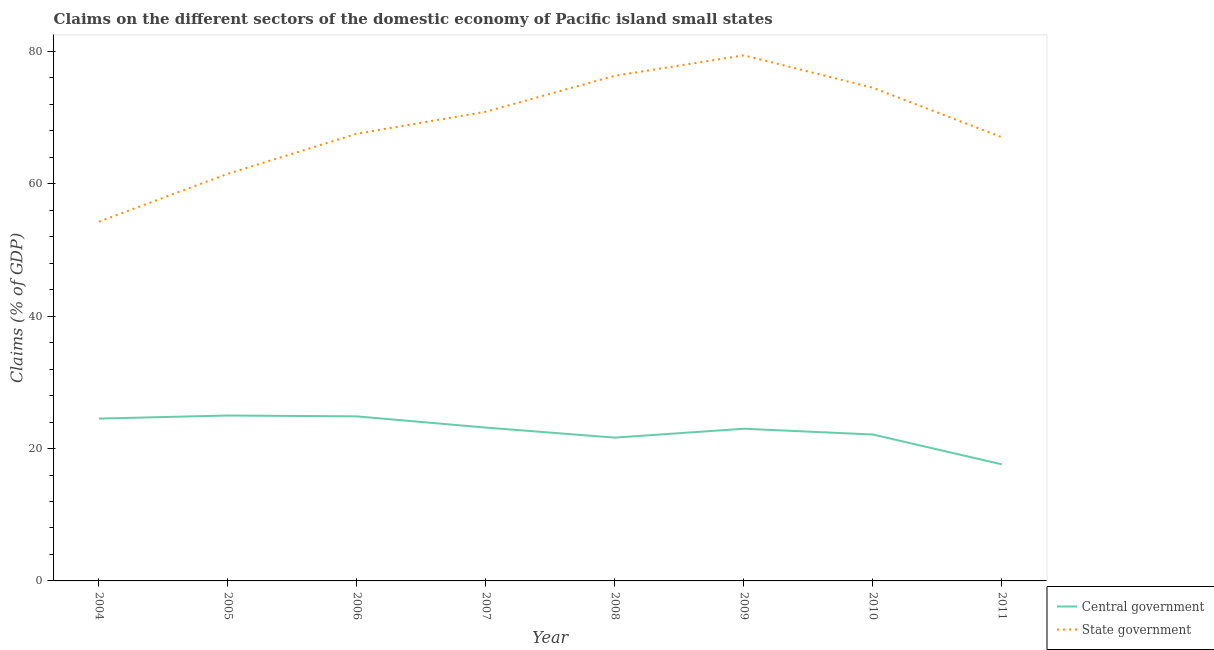What is the claims on state government in 2008?
Give a very brief answer. 76.31. Across all years, what is the maximum claims on state government?
Provide a succinct answer. 79.4. Across all years, what is the minimum claims on state government?
Provide a succinct answer. 54.27. In which year was the claims on central government maximum?
Offer a terse response. 2005. What is the total claims on state government in the graph?
Your response must be concise. 551.47. What is the difference between the claims on state government in 2007 and that in 2010?
Give a very brief answer. -3.62. What is the difference between the claims on central government in 2009 and the claims on state government in 2004?
Keep it short and to the point. -31.28. What is the average claims on central government per year?
Your response must be concise. 22.74. In the year 2011, what is the difference between the claims on central government and claims on state government?
Give a very brief answer. -49.42. In how many years, is the claims on central government greater than 40 %?
Your answer should be compact. 0. What is the ratio of the claims on central government in 2004 to that in 2009?
Keep it short and to the point. 1.07. Is the claims on state government in 2006 less than that in 2009?
Offer a terse response. Yes. Is the difference between the claims on state government in 2007 and 2009 greater than the difference between the claims on central government in 2007 and 2009?
Provide a succinct answer. No. What is the difference between the highest and the second highest claims on state government?
Provide a short and direct response. 3.09. What is the difference between the highest and the lowest claims on central government?
Ensure brevity in your answer.  7.38. In how many years, is the claims on central government greater than the average claims on central government taken over all years?
Give a very brief answer. 5. Does the claims on state government monotonically increase over the years?
Provide a short and direct response. No. Is the claims on state government strictly greater than the claims on central government over the years?
Offer a terse response. Yes. Is the claims on central government strictly less than the claims on state government over the years?
Ensure brevity in your answer.  Yes. How many lines are there?
Offer a terse response. 2. What is the difference between two consecutive major ticks on the Y-axis?
Keep it short and to the point. 20. Are the values on the major ticks of Y-axis written in scientific E-notation?
Your answer should be compact. No. Does the graph contain grids?
Offer a terse response. No. Where does the legend appear in the graph?
Provide a succinct answer. Bottom right. How are the legend labels stacked?
Offer a very short reply. Vertical. What is the title of the graph?
Offer a very short reply. Claims on the different sectors of the domestic economy of Pacific island small states. What is the label or title of the X-axis?
Your answer should be compact. Year. What is the label or title of the Y-axis?
Provide a succinct answer. Claims (% of GDP). What is the Claims (% of GDP) in Central government in 2004?
Offer a terse response. 24.52. What is the Claims (% of GDP) of State government in 2004?
Make the answer very short. 54.27. What is the Claims (% of GDP) in Central government in 2005?
Provide a succinct answer. 24.99. What is the Claims (% of GDP) of State government in 2005?
Give a very brief answer. 61.51. What is the Claims (% of GDP) of Central government in 2006?
Your response must be concise. 24.86. What is the Claims (% of GDP) in State government in 2006?
Your response must be concise. 67.56. What is the Claims (% of GDP) in Central government in 2007?
Provide a short and direct response. 23.16. What is the Claims (% of GDP) in State government in 2007?
Give a very brief answer. 70.88. What is the Claims (% of GDP) of Central government in 2008?
Your answer should be very brief. 21.65. What is the Claims (% of GDP) in State government in 2008?
Give a very brief answer. 76.31. What is the Claims (% of GDP) of Central government in 2009?
Offer a very short reply. 22.99. What is the Claims (% of GDP) in State government in 2009?
Provide a short and direct response. 79.4. What is the Claims (% of GDP) of Central government in 2010?
Provide a succinct answer. 22.12. What is the Claims (% of GDP) in State government in 2010?
Offer a terse response. 74.5. What is the Claims (% of GDP) of Central government in 2011?
Offer a very short reply. 17.61. What is the Claims (% of GDP) of State government in 2011?
Your answer should be compact. 67.03. Across all years, what is the maximum Claims (% of GDP) in Central government?
Your response must be concise. 24.99. Across all years, what is the maximum Claims (% of GDP) of State government?
Offer a very short reply. 79.4. Across all years, what is the minimum Claims (% of GDP) of Central government?
Keep it short and to the point. 17.61. Across all years, what is the minimum Claims (% of GDP) in State government?
Give a very brief answer. 54.27. What is the total Claims (% of GDP) of Central government in the graph?
Ensure brevity in your answer.  181.9. What is the total Claims (% of GDP) of State government in the graph?
Your response must be concise. 551.47. What is the difference between the Claims (% of GDP) in Central government in 2004 and that in 2005?
Offer a terse response. -0.47. What is the difference between the Claims (% of GDP) of State government in 2004 and that in 2005?
Provide a succinct answer. -7.24. What is the difference between the Claims (% of GDP) of Central government in 2004 and that in 2006?
Keep it short and to the point. -0.34. What is the difference between the Claims (% of GDP) in State government in 2004 and that in 2006?
Offer a terse response. -13.29. What is the difference between the Claims (% of GDP) of Central government in 2004 and that in 2007?
Offer a terse response. 1.36. What is the difference between the Claims (% of GDP) in State government in 2004 and that in 2007?
Provide a succinct answer. -16.61. What is the difference between the Claims (% of GDP) in Central government in 2004 and that in 2008?
Give a very brief answer. 2.87. What is the difference between the Claims (% of GDP) of State government in 2004 and that in 2008?
Your answer should be compact. -22.04. What is the difference between the Claims (% of GDP) of Central government in 2004 and that in 2009?
Offer a terse response. 1.53. What is the difference between the Claims (% of GDP) in State government in 2004 and that in 2009?
Give a very brief answer. -25.13. What is the difference between the Claims (% of GDP) of Central government in 2004 and that in 2010?
Keep it short and to the point. 2.4. What is the difference between the Claims (% of GDP) of State government in 2004 and that in 2010?
Make the answer very short. -20.23. What is the difference between the Claims (% of GDP) of Central government in 2004 and that in 2011?
Ensure brevity in your answer.  6.91. What is the difference between the Claims (% of GDP) of State government in 2004 and that in 2011?
Offer a terse response. -12.76. What is the difference between the Claims (% of GDP) in Central government in 2005 and that in 2006?
Offer a terse response. 0.13. What is the difference between the Claims (% of GDP) in State government in 2005 and that in 2006?
Provide a short and direct response. -6.05. What is the difference between the Claims (% of GDP) of Central government in 2005 and that in 2007?
Give a very brief answer. 1.83. What is the difference between the Claims (% of GDP) of State government in 2005 and that in 2007?
Your response must be concise. -9.37. What is the difference between the Claims (% of GDP) of Central government in 2005 and that in 2008?
Ensure brevity in your answer.  3.34. What is the difference between the Claims (% of GDP) of State government in 2005 and that in 2008?
Keep it short and to the point. -14.8. What is the difference between the Claims (% of GDP) of Central government in 2005 and that in 2009?
Your answer should be compact. 2. What is the difference between the Claims (% of GDP) of State government in 2005 and that in 2009?
Your response must be concise. -17.89. What is the difference between the Claims (% of GDP) in Central government in 2005 and that in 2010?
Make the answer very short. 2.87. What is the difference between the Claims (% of GDP) in State government in 2005 and that in 2010?
Keep it short and to the point. -12.99. What is the difference between the Claims (% of GDP) of Central government in 2005 and that in 2011?
Offer a very short reply. 7.38. What is the difference between the Claims (% of GDP) in State government in 2005 and that in 2011?
Keep it short and to the point. -5.52. What is the difference between the Claims (% of GDP) in Central government in 2006 and that in 2007?
Ensure brevity in your answer.  1.69. What is the difference between the Claims (% of GDP) of State government in 2006 and that in 2007?
Provide a succinct answer. -3.32. What is the difference between the Claims (% of GDP) in Central government in 2006 and that in 2008?
Offer a terse response. 3.21. What is the difference between the Claims (% of GDP) of State government in 2006 and that in 2008?
Make the answer very short. -8.75. What is the difference between the Claims (% of GDP) of Central government in 2006 and that in 2009?
Give a very brief answer. 1.87. What is the difference between the Claims (% of GDP) in State government in 2006 and that in 2009?
Provide a succinct answer. -11.84. What is the difference between the Claims (% of GDP) of Central government in 2006 and that in 2010?
Offer a very short reply. 2.74. What is the difference between the Claims (% of GDP) of State government in 2006 and that in 2010?
Provide a short and direct response. -6.94. What is the difference between the Claims (% of GDP) of Central government in 2006 and that in 2011?
Your response must be concise. 7.25. What is the difference between the Claims (% of GDP) of State government in 2006 and that in 2011?
Your answer should be compact. 0.53. What is the difference between the Claims (% of GDP) in Central government in 2007 and that in 2008?
Your answer should be compact. 1.52. What is the difference between the Claims (% of GDP) in State government in 2007 and that in 2008?
Your answer should be very brief. -5.43. What is the difference between the Claims (% of GDP) of Central government in 2007 and that in 2009?
Provide a short and direct response. 0.17. What is the difference between the Claims (% of GDP) in State government in 2007 and that in 2009?
Offer a terse response. -8.52. What is the difference between the Claims (% of GDP) in Central government in 2007 and that in 2010?
Provide a short and direct response. 1.05. What is the difference between the Claims (% of GDP) of State government in 2007 and that in 2010?
Your answer should be compact. -3.62. What is the difference between the Claims (% of GDP) in Central government in 2007 and that in 2011?
Your answer should be compact. 5.55. What is the difference between the Claims (% of GDP) of State government in 2007 and that in 2011?
Offer a terse response. 3.85. What is the difference between the Claims (% of GDP) of Central government in 2008 and that in 2009?
Your answer should be compact. -1.34. What is the difference between the Claims (% of GDP) of State government in 2008 and that in 2009?
Give a very brief answer. -3.09. What is the difference between the Claims (% of GDP) of Central government in 2008 and that in 2010?
Give a very brief answer. -0.47. What is the difference between the Claims (% of GDP) of State government in 2008 and that in 2010?
Your answer should be very brief. 1.81. What is the difference between the Claims (% of GDP) in Central government in 2008 and that in 2011?
Provide a short and direct response. 4.04. What is the difference between the Claims (% of GDP) of State government in 2008 and that in 2011?
Your answer should be very brief. 9.28. What is the difference between the Claims (% of GDP) of Central government in 2009 and that in 2010?
Ensure brevity in your answer.  0.87. What is the difference between the Claims (% of GDP) of State government in 2009 and that in 2010?
Provide a short and direct response. 4.9. What is the difference between the Claims (% of GDP) of Central government in 2009 and that in 2011?
Your answer should be very brief. 5.38. What is the difference between the Claims (% of GDP) of State government in 2009 and that in 2011?
Make the answer very short. 12.37. What is the difference between the Claims (% of GDP) of Central government in 2010 and that in 2011?
Make the answer very short. 4.5. What is the difference between the Claims (% of GDP) of State government in 2010 and that in 2011?
Your answer should be compact. 7.47. What is the difference between the Claims (% of GDP) of Central government in 2004 and the Claims (% of GDP) of State government in 2005?
Your response must be concise. -36.99. What is the difference between the Claims (% of GDP) in Central government in 2004 and the Claims (% of GDP) in State government in 2006?
Keep it short and to the point. -43.04. What is the difference between the Claims (% of GDP) of Central government in 2004 and the Claims (% of GDP) of State government in 2007?
Offer a very short reply. -46.36. What is the difference between the Claims (% of GDP) of Central government in 2004 and the Claims (% of GDP) of State government in 2008?
Offer a very short reply. -51.79. What is the difference between the Claims (% of GDP) of Central government in 2004 and the Claims (% of GDP) of State government in 2009?
Your answer should be very brief. -54.88. What is the difference between the Claims (% of GDP) in Central government in 2004 and the Claims (% of GDP) in State government in 2010?
Your answer should be compact. -49.98. What is the difference between the Claims (% of GDP) of Central government in 2004 and the Claims (% of GDP) of State government in 2011?
Your answer should be very brief. -42.51. What is the difference between the Claims (% of GDP) in Central government in 2005 and the Claims (% of GDP) in State government in 2006?
Give a very brief answer. -42.57. What is the difference between the Claims (% of GDP) in Central government in 2005 and the Claims (% of GDP) in State government in 2007?
Keep it short and to the point. -45.89. What is the difference between the Claims (% of GDP) in Central government in 2005 and the Claims (% of GDP) in State government in 2008?
Give a very brief answer. -51.32. What is the difference between the Claims (% of GDP) of Central government in 2005 and the Claims (% of GDP) of State government in 2009?
Your answer should be very brief. -54.41. What is the difference between the Claims (% of GDP) in Central government in 2005 and the Claims (% of GDP) in State government in 2010?
Make the answer very short. -49.51. What is the difference between the Claims (% of GDP) in Central government in 2005 and the Claims (% of GDP) in State government in 2011?
Provide a short and direct response. -42.04. What is the difference between the Claims (% of GDP) in Central government in 2006 and the Claims (% of GDP) in State government in 2007?
Your answer should be very brief. -46.02. What is the difference between the Claims (% of GDP) in Central government in 2006 and the Claims (% of GDP) in State government in 2008?
Make the answer very short. -51.46. What is the difference between the Claims (% of GDP) in Central government in 2006 and the Claims (% of GDP) in State government in 2009?
Make the answer very short. -54.54. What is the difference between the Claims (% of GDP) of Central government in 2006 and the Claims (% of GDP) of State government in 2010?
Offer a very short reply. -49.64. What is the difference between the Claims (% of GDP) in Central government in 2006 and the Claims (% of GDP) in State government in 2011?
Give a very brief answer. -42.17. What is the difference between the Claims (% of GDP) of Central government in 2007 and the Claims (% of GDP) of State government in 2008?
Ensure brevity in your answer.  -53.15. What is the difference between the Claims (% of GDP) of Central government in 2007 and the Claims (% of GDP) of State government in 2009?
Provide a short and direct response. -56.24. What is the difference between the Claims (% of GDP) of Central government in 2007 and the Claims (% of GDP) of State government in 2010?
Provide a short and direct response. -51.34. What is the difference between the Claims (% of GDP) of Central government in 2007 and the Claims (% of GDP) of State government in 2011?
Make the answer very short. -43.87. What is the difference between the Claims (% of GDP) of Central government in 2008 and the Claims (% of GDP) of State government in 2009?
Give a very brief answer. -57.75. What is the difference between the Claims (% of GDP) of Central government in 2008 and the Claims (% of GDP) of State government in 2010?
Offer a terse response. -52.85. What is the difference between the Claims (% of GDP) of Central government in 2008 and the Claims (% of GDP) of State government in 2011?
Make the answer very short. -45.38. What is the difference between the Claims (% of GDP) in Central government in 2009 and the Claims (% of GDP) in State government in 2010?
Your answer should be compact. -51.51. What is the difference between the Claims (% of GDP) in Central government in 2009 and the Claims (% of GDP) in State government in 2011?
Your response must be concise. -44.04. What is the difference between the Claims (% of GDP) of Central government in 2010 and the Claims (% of GDP) of State government in 2011?
Keep it short and to the point. -44.91. What is the average Claims (% of GDP) in Central government per year?
Make the answer very short. 22.74. What is the average Claims (% of GDP) of State government per year?
Offer a terse response. 68.93. In the year 2004, what is the difference between the Claims (% of GDP) in Central government and Claims (% of GDP) in State government?
Keep it short and to the point. -29.75. In the year 2005, what is the difference between the Claims (% of GDP) in Central government and Claims (% of GDP) in State government?
Make the answer very short. -36.52. In the year 2006, what is the difference between the Claims (% of GDP) of Central government and Claims (% of GDP) of State government?
Make the answer very short. -42.7. In the year 2007, what is the difference between the Claims (% of GDP) of Central government and Claims (% of GDP) of State government?
Your answer should be very brief. -47.71. In the year 2008, what is the difference between the Claims (% of GDP) in Central government and Claims (% of GDP) in State government?
Keep it short and to the point. -54.66. In the year 2009, what is the difference between the Claims (% of GDP) in Central government and Claims (% of GDP) in State government?
Offer a very short reply. -56.41. In the year 2010, what is the difference between the Claims (% of GDP) of Central government and Claims (% of GDP) of State government?
Provide a short and direct response. -52.38. In the year 2011, what is the difference between the Claims (% of GDP) in Central government and Claims (% of GDP) in State government?
Ensure brevity in your answer.  -49.42. What is the ratio of the Claims (% of GDP) in Central government in 2004 to that in 2005?
Give a very brief answer. 0.98. What is the ratio of the Claims (% of GDP) in State government in 2004 to that in 2005?
Ensure brevity in your answer.  0.88. What is the ratio of the Claims (% of GDP) in Central government in 2004 to that in 2006?
Your answer should be compact. 0.99. What is the ratio of the Claims (% of GDP) of State government in 2004 to that in 2006?
Your answer should be compact. 0.8. What is the ratio of the Claims (% of GDP) in Central government in 2004 to that in 2007?
Make the answer very short. 1.06. What is the ratio of the Claims (% of GDP) of State government in 2004 to that in 2007?
Your answer should be very brief. 0.77. What is the ratio of the Claims (% of GDP) of Central government in 2004 to that in 2008?
Your answer should be very brief. 1.13. What is the ratio of the Claims (% of GDP) in State government in 2004 to that in 2008?
Provide a short and direct response. 0.71. What is the ratio of the Claims (% of GDP) of Central government in 2004 to that in 2009?
Offer a terse response. 1.07. What is the ratio of the Claims (% of GDP) of State government in 2004 to that in 2009?
Offer a terse response. 0.68. What is the ratio of the Claims (% of GDP) of Central government in 2004 to that in 2010?
Ensure brevity in your answer.  1.11. What is the ratio of the Claims (% of GDP) in State government in 2004 to that in 2010?
Your answer should be very brief. 0.73. What is the ratio of the Claims (% of GDP) in Central government in 2004 to that in 2011?
Give a very brief answer. 1.39. What is the ratio of the Claims (% of GDP) of State government in 2004 to that in 2011?
Your answer should be compact. 0.81. What is the ratio of the Claims (% of GDP) in Central government in 2005 to that in 2006?
Your answer should be very brief. 1.01. What is the ratio of the Claims (% of GDP) of State government in 2005 to that in 2006?
Offer a terse response. 0.91. What is the ratio of the Claims (% of GDP) of Central government in 2005 to that in 2007?
Ensure brevity in your answer.  1.08. What is the ratio of the Claims (% of GDP) of State government in 2005 to that in 2007?
Ensure brevity in your answer.  0.87. What is the ratio of the Claims (% of GDP) of Central government in 2005 to that in 2008?
Offer a terse response. 1.15. What is the ratio of the Claims (% of GDP) in State government in 2005 to that in 2008?
Offer a terse response. 0.81. What is the ratio of the Claims (% of GDP) of Central government in 2005 to that in 2009?
Give a very brief answer. 1.09. What is the ratio of the Claims (% of GDP) in State government in 2005 to that in 2009?
Offer a very short reply. 0.77. What is the ratio of the Claims (% of GDP) of Central government in 2005 to that in 2010?
Keep it short and to the point. 1.13. What is the ratio of the Claims (% of GDP) in State government in 2005 to that in 2010?
Offer a terse response. 0.83. What is the ratio of the Claims (% of GDP) in Central government in 2005 to that in 2011?
Ensure brevity in your answer.  1.42. What is the ratio of the Claims (% of GDP) of State government in 2005 to that in 2011?
Provide a succinct answer. 0.92. What is the ratio of the Claims (% of GDP) of Central government in 2006 to that in 2007?
Provide a succinct answer. 1.07. What is the ratio of the Claims (% of GDP) in State government in 2006 to that in 2007?
Ensure brevity in your answer.  0.95. What is the ratio of the Claims (% of GDP) of Central government in 2006 to that in 2008?
Provide a succinct answer. 1.15. What is the ratio of the Claims (% of GDP) of State government in 2006 to that in 2008?
Ensure brevity in your answer.  0.89. What is the ratio of the Claims (% of GDP) in Central government in 2006 to that in 2009?
Ensure brevity in your answer.  1.08. What is the ratio of the Claims (% of GDP) in State government in 2006 to that in 2009?
Ensure brevity in your answer.  0.85. What is the ratio of the Claims (% of GDP) of Central government in 2006 to that in 2010?
Offer a very short reply. 1.12. What is the ratio of the Claims (% of GDP) of State government in 2006 to that in 2010?
Offer a very short reply. 0.91. What is the ratio of the Claims (% of GDP) in Central government in 2006 to that in 2011?
Your response must be concise. 1.41. What is the ratio of the Claims (% of GDP) in State government in 2006 to that in 2011?
Offer a very short reply. 1.01. What is the ratio of the Claims (% of GDP) in Central government in 2007 to that in 2008?
Provide a succinct answer. 1.07. What is the ratio of the Claims (% of GDP) of State government in 2007 to that in 2008?
Provide a short and direct response. 0.93. What is the ratio of the Claims (% of GDP) in Central government in 2007 to that in 2009?
Keep it short and to the point. 1.01. What is the ratio of the Claims (% of GDP) of State government in 2007 to that in 2009?
Keep it short and to the point. 0.89. What is the ratio of the Claims (% of GDP) in Central government in 2007 to that in 2010?
Offer a terse response. 1.05. What is the ratio of the Claims (% of GDP) of State government in 2007 to that in 2010?
Provide a succinct answer. 0.95. What is the ratio of the Claims (% of GDP) of Central government in 2007 to that in 2011?
Your answer should be very brief. 1.32. What is the ratio of the Claims (% of GDP) of State government in 2007 to that in 2011?
Give a very brief answer. 1.06. What is the ratio of the Claims (% of GDP) in Central government in 2008 to that in 2009?
Your answer should be compact. 0.94. What is the ratio of the Claims (% of GDP) of State government in 2008 to that in 2009?
Ensure brevity in your answer.  0.96. What is the ratio of the Claims (% of GDP) in Central government in 2008 to that in 2010?
Provide a short and direct response. 0.98. What is the ratio of the Claims (% of GDP) in State government in 2008 to that in 2010?
Provide a short and direct response. 1.02. What is the ratio of the Claims (% of GDP) in Central government in 2008 to that in 2011?
Ensure brevity in your answer.  1.23. What is the ratio of the Claims (% of GDP) in State government in 2008 to that in 2011?
Your response must be concise. 1.14. What is the ratio of the Claims (% of GDP) in Central government in 2009 to that in 2010?
Your response must be concise. 1.04. What is the ratio of the Claims (% of GDP) in State government in 2009 to that in 2010?
Offer a very short reply. 1.07. What is the ratio of the Claims (% of GDP) of Central government in 2009 to that in 2011?
Your answer should be very brief. 1.31. What is the ratio of the Claims (% of GDP) of State government in 2009 to that in 2011?
Ensure brevity in your answer.  1.18. What is the ratio of the Claims (% of GDP) of Central government in 2010 to that in 2011?
Your answer should be compact. 1.26. What is the ratio of the Claims (% of GDP) of State government in 2010 to that in 2011?
Your answer should be very brief. 1.11. What is the difference between the highest and the second highest Claims (% of GDP) in Central government?
Give a very brief answer. 0.13. What is the difference between the highest and the second highest Claims (% of GDP) of State government?
Give a very brief answer. 3.09. What is the difference between the highest and the lowest Claims (% of GDP) of Central government?
Ensure brevity in your answer.  7.38. What is the difference between the highest and the lowest Claims (% of GDP) of State government?
Make the answer very short. 25.13. 